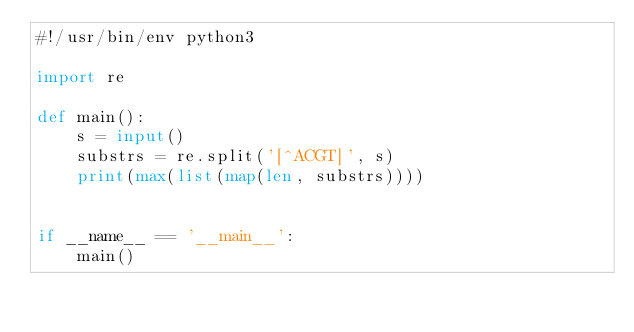<code> <loc_0><loc_0><loc_500><loc_500><_Python_>#!/usr/bin/env python3

import re

def main():
    s = input()
    substrs = re.split('[^ACGT]', s)
    print(max(list(map(len, substrs))))


if __name__ == '__main__':
    main()
</code> 